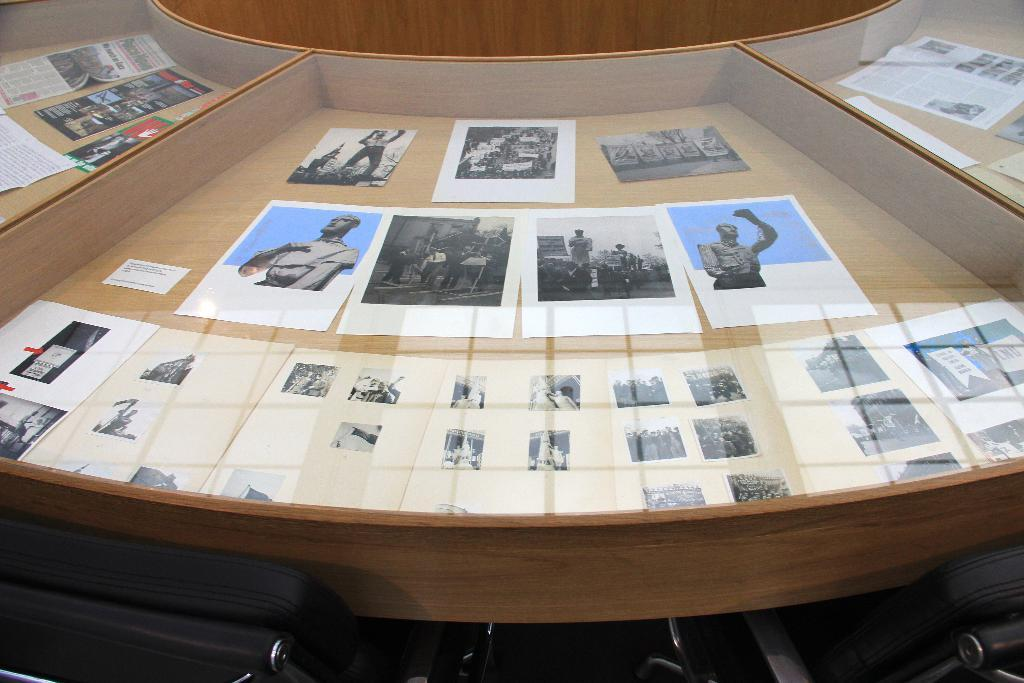What type of furniture is present in the image? There is a wooden display cabinet in the image. What is inside the display cabinet? The display cabinet contains posters. Is there a crown displayed on top of the wooden display cabinet in the image? No, there is no crown present in the image. 